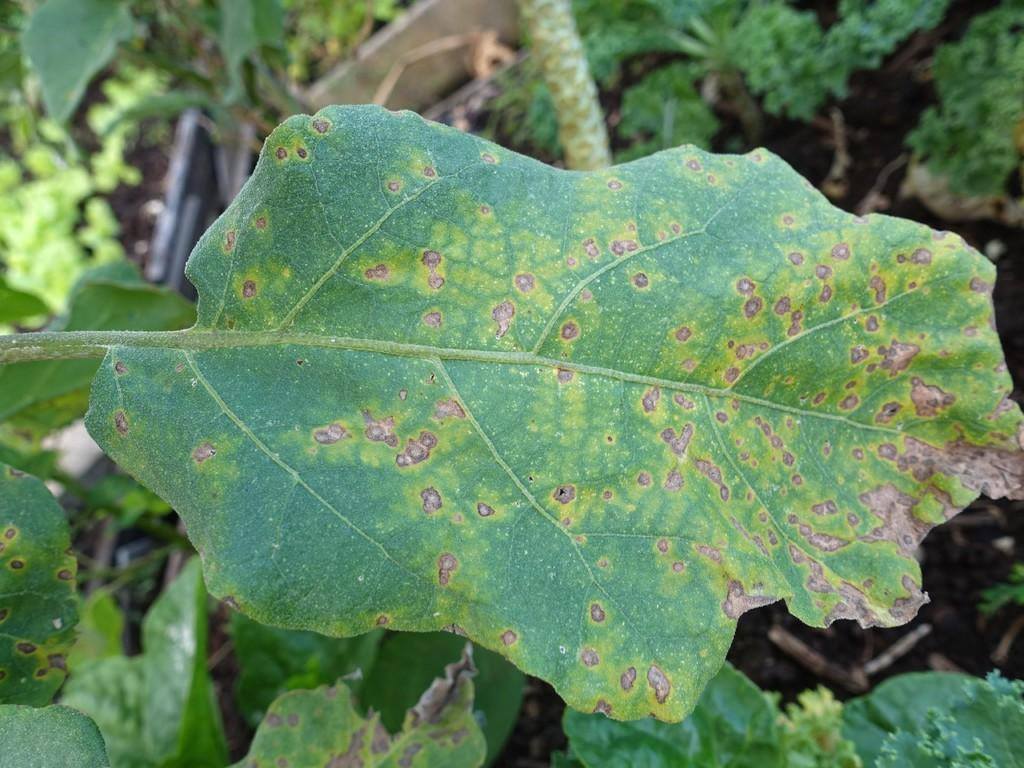What type of living organisms can be seen in the image? Plants can be seen in the image. What else is present on the ground in the image? There are objects on the ground in the image. What is the purpose of the finger in the image? There is no finger present in the image, so it is not possible to determine its purpose. 